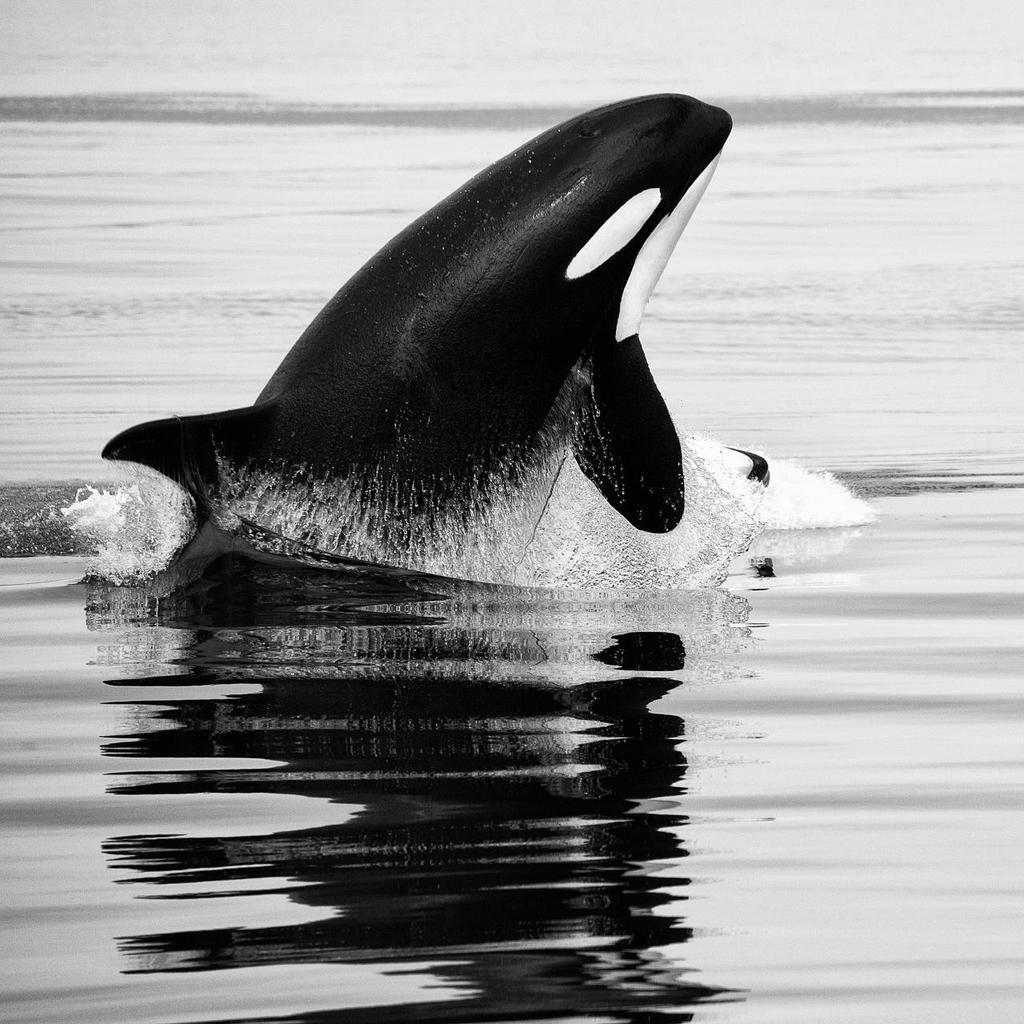What type of animal can be seen in the image? There is an aquatic animal in the image. What color scheme is used in the image? The image is black and white. What type of engine can be heard in the background of the image? There is no engine or sound present in the image, as it is a still image of an aquatic animal. Can you identify any birds, such as a robin, in the image? There are no birds visible in the image; it features an aquatic animal. 